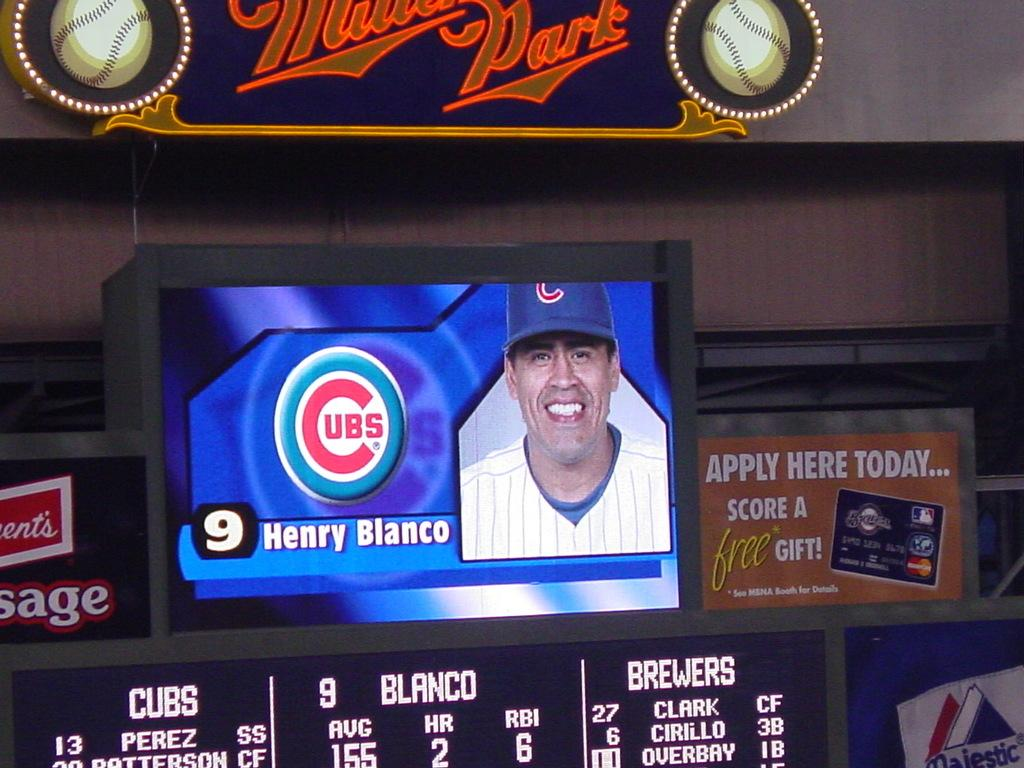<image>
Give a short and clear explanation of the subsequent image. a baseball field with a screen showing number 9 henry blanco 